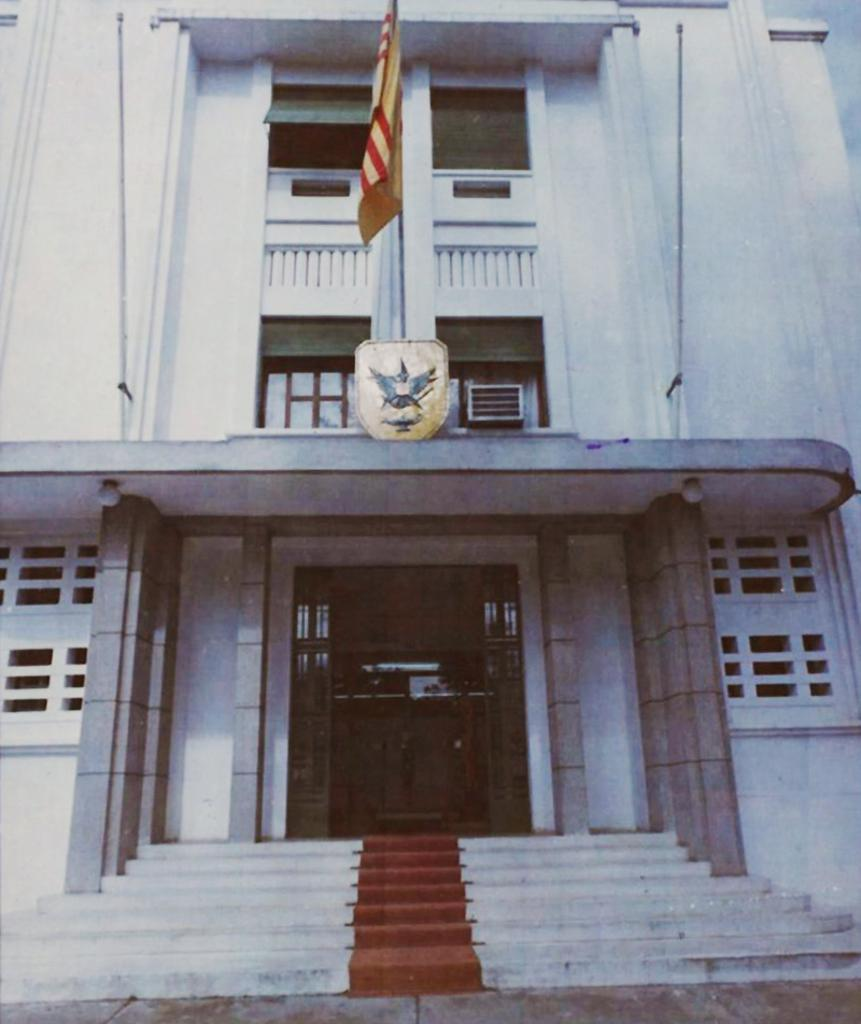What type of structure is visible in the image? There is a building with windows in the image. What is attached to the building? There is a flag with a pole in the image. What is located near the flag? There is a logo near the flag in the image. What architectural feature is present in the image? There are steps in the image. What color of paint is used on the table in the image? There is no table present in the image, so it is not possible to determine the color of paint used on it. 